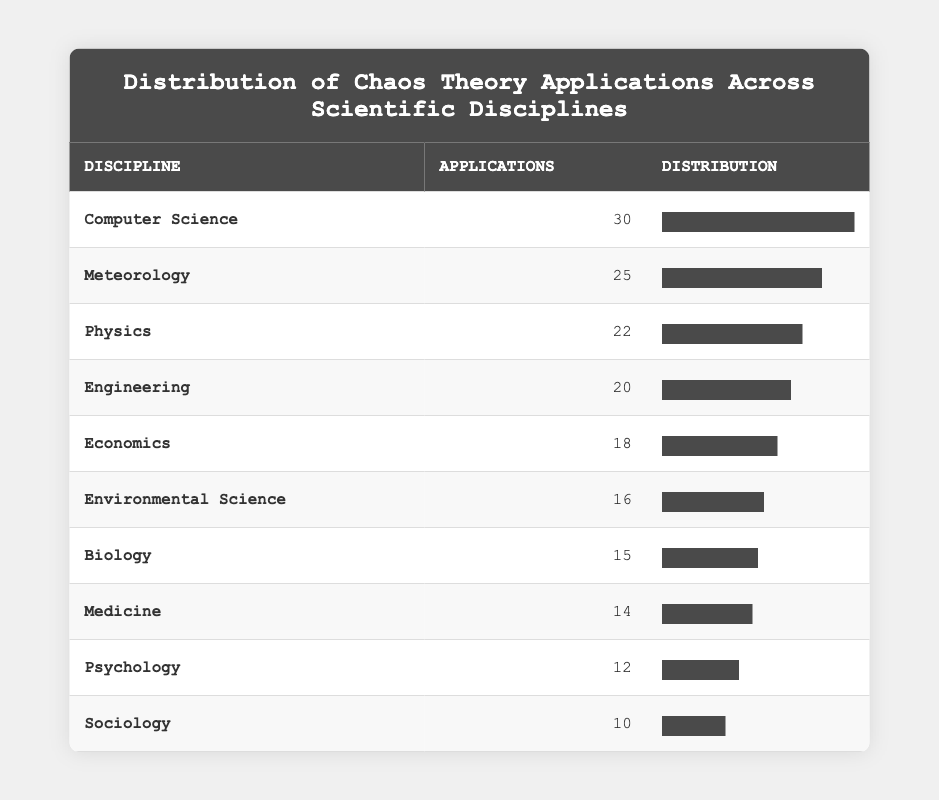What is the discipline with the highest number of applications of chaos theory? The table lists applications by discipline. The discipline with the highest applications is "Computer Science" with 30 applications.
Answer: Computer Science How many applications of chaos theory are there in Meteorology? The table directly states that there are 25 applications of chaos theory in Meteorology.
Answer: 25 What is the total number of applications of chaos theory across all listed disciplines? To find the total, add the applications from each discipline: 30 + 25 + 22 + 20 + 18 + 16 + 15 + 14 + 12 + 10 = 252.
Answer: 252 Which discipline has the least number of applications of chaos theory, and how many applications does it have? By reviewing the table, "Sociology" has the least applications at 10.
Answer: Sociology, 10 Is the number of applications in Biology greater than the number of applications in Medicine? The table shows 15 applications in Biology and 14 in Medicine. Since 15 is greater than 14, the statement is true.
Answer: Yes What are the two disciplines with applications of chaos theory totaling more than 40? Looking at the applications, "Computer Science" (30) and "Meteorology" (25) total to 55, which is more than 40. Therefore, Computer Science and Meteorology qualify.
Answer: Computer Science, Meteorology What is the median number of applications of chaos theory across the listed disciplines? To find the median, first, arrange the application numbers in order: 10, 12, 14, 15, 16, 18, 20, 22, 25, 30. As there are 10 values, the median is the average of the 5th and 6th values: (16 + 18)/2 = 17.
Answer: 17 How many disciplines have 20 or more applications of chaos theory? From the table, the disciplines with 20 or more applications are Computer Science (30), Meteorology (25), Physics (22), and Engineering (20). This totals to 4 disciplines.
Answer: 4 Which discipline has a number of applications closest to the average number across all disciplines? The total applications is 252, with 10 disciplines, leading to an average of 252/10 = 25.2. The closest application count to this average is Meteorology (25), which is 0.2 away and the closest to the average.
Answer: Meteorology 